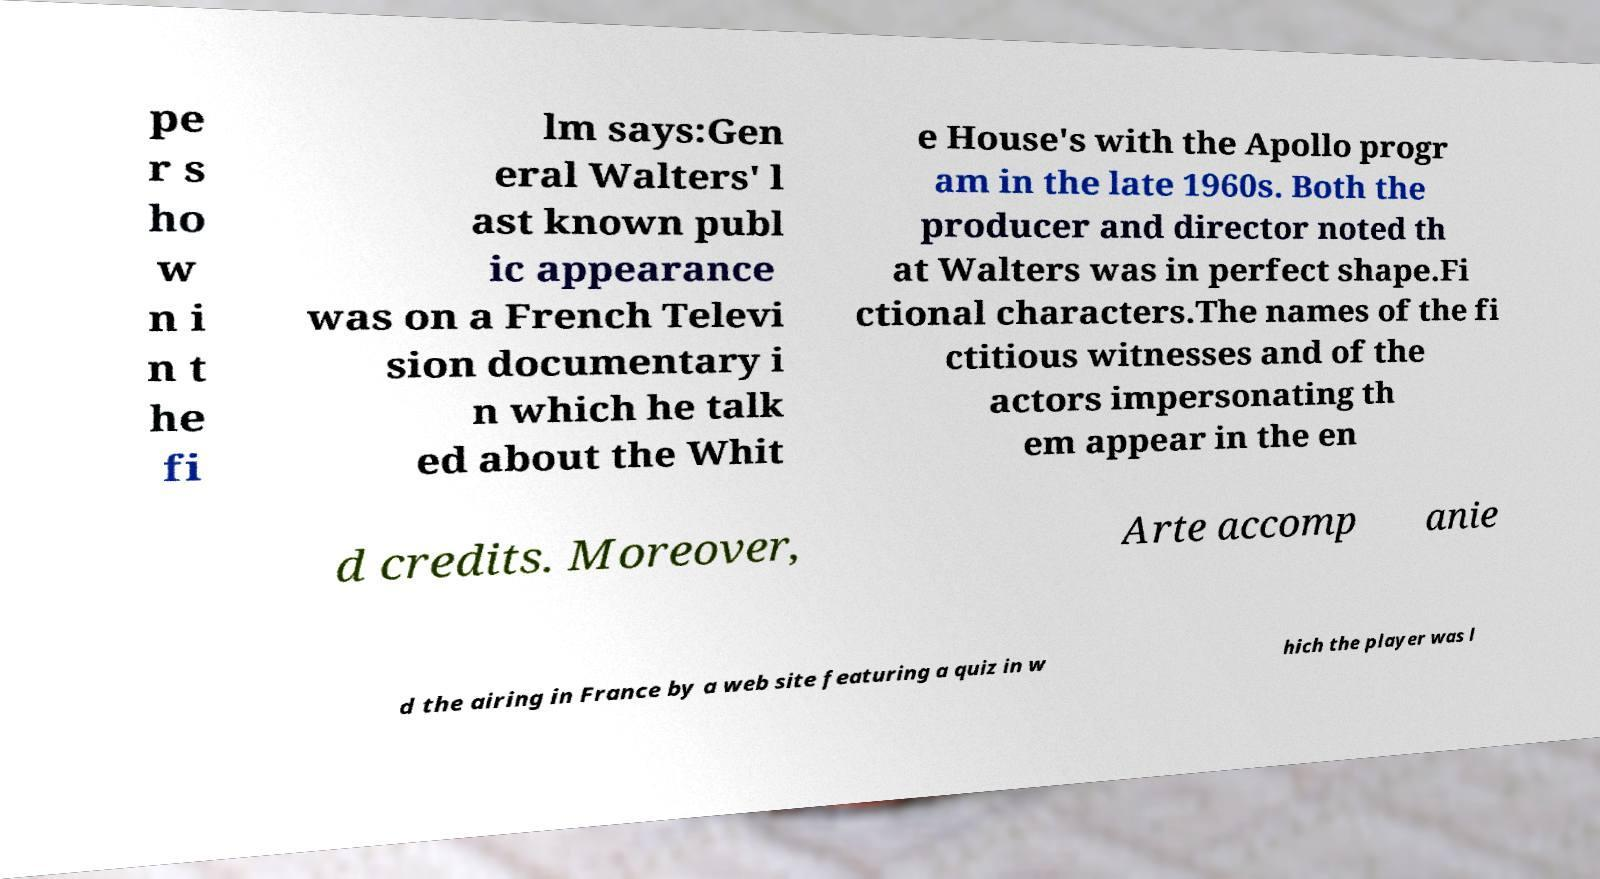For documentation purposes, I need the text within this image transcribed. Could you provide that? pe r s ho w n i n t he fi lm says:Gen eral Walters' l ast known publ ic appearance was on a French Televi sion documentary i n which he talk ed about the Whit e House's with the Apollo progr am in the late 1960s. Both the producer and director noted th at Walters was in perfect shape.Fi ctional characters.The names of the fi ctitious witnesses and of the actors impersonating th em appear in the en d credits. Moreover, Arte accomp anie d the airing in France by a web site featuring a quiz in w hich the player was l 